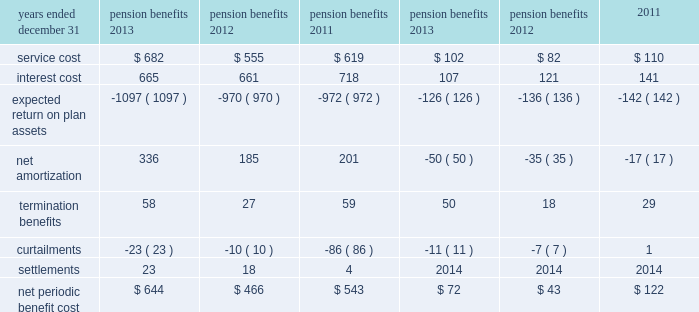13 .
Pension and other postretirement benefit plans the company has defined benefit pension plans covering eligible employees in the united states and in certain of its international subsidiaries .
As a result of plan design changes approved in 2011 , beginning on january 1 , 2013 , active participants in merck 2019s primary u.s .
Defined benefit pension plans are accruing pension benefits using new cash balance formulas based on age , service , pay and interest .
However , during a transition period from january 1 , 2013 through december 31 , 2019 , participants will earn the greater of the benefit as calculated under the employee 2019s legacy final average pay formula or their new cash balance formula .
For all years of service after december 31 , 2019 , participants will earn future benefits under only the cash balance formula .
In addition , the company provides medical benefits , principally to its eligible u.s .
Retirees and their dependents , through its other postretirement benefit plans .
The company uses december 31 as the year-end measurement date for all of its pension plans and other postretirement benefit plans .
Net periodic benefit cost the net periodic benefit cost for pension and other postretirement benefit plans consisted of the following components: .
The increase in net periodic benefit cost for pension and other postretirement benefit plans in 2013 as compared with 2012 is largely attributable to a change in the discount rate .
The net periodic benefit cost attributable to u.s .
Pension plans included in the above table was $ 348 million in 2013 , $ 268 million in 2012 and $ 406 million in in connection with restructuring actions ( see note 3 ) , termination charges were recorded in 2013 , 2012 and 2011 on pension and other postretirement benefit plans related to expanded eligibility for certain employees exiting merck .
Also , in connection with these restructuring activities , curtailments were recorded in 2013 , 2012 and 2011 on pension and other postretirement benefit plans .
In addition , settlements were recorded in 2013 , 2012 and 2011 on certain domestic and international pension plans .
Table of contents .
What was the percentage change in the net amortization from 2012 to 2013? 
Computations: ((336 - 185) / 185)
Answer: 0.81622. 